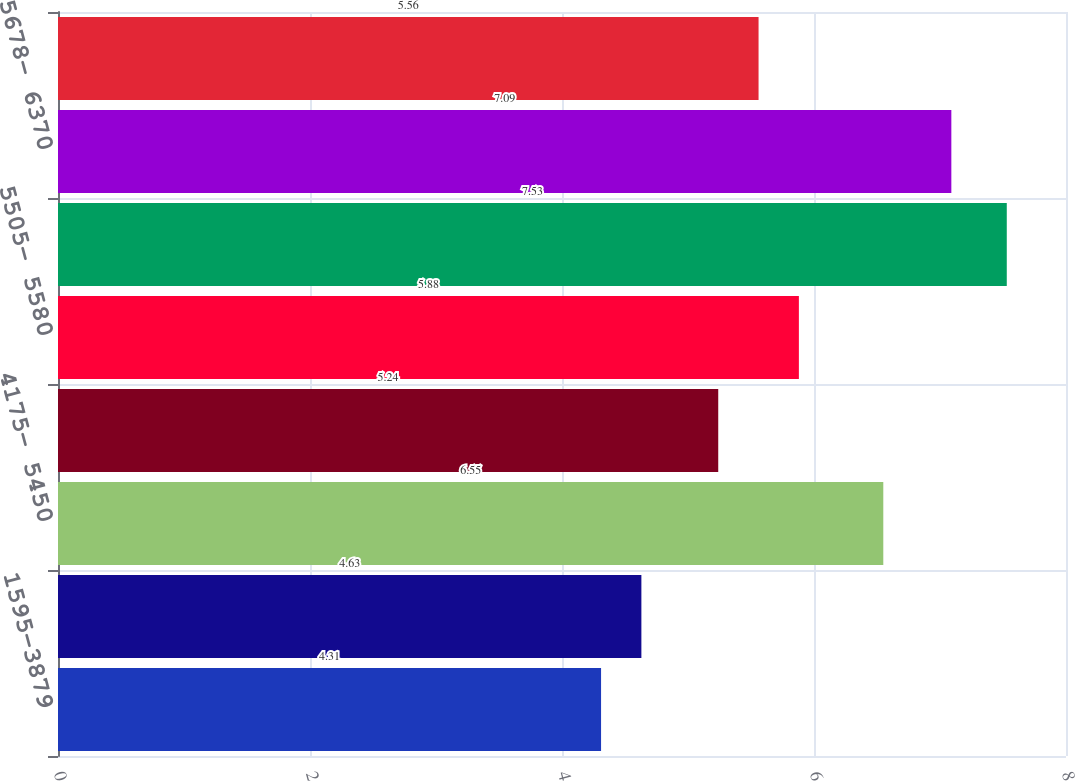Convert chart. <chart><loc_0><loc_0><loc_500><loc_500><bar_chart><fcel>1595-3879<fcel>4126- 4126<fcel>4175- 5450<fcel>5477- 5477<fcel>5505- 5580<fcel>5624- 5624<fcel>5678- 6370<fcel>1595-6370<nl><fcel>4.31<fcel>4.63<fcel>6.55<fcel>5.24<fcel>5.88<fcel>7.53<fcel>7.09<fcel>5.56<nl></chart> 